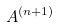Convert formula to latex. <formula><loc_0><loc_0><loc_500><loc_500>A ^ { ( n + 1 ) }</formula> 